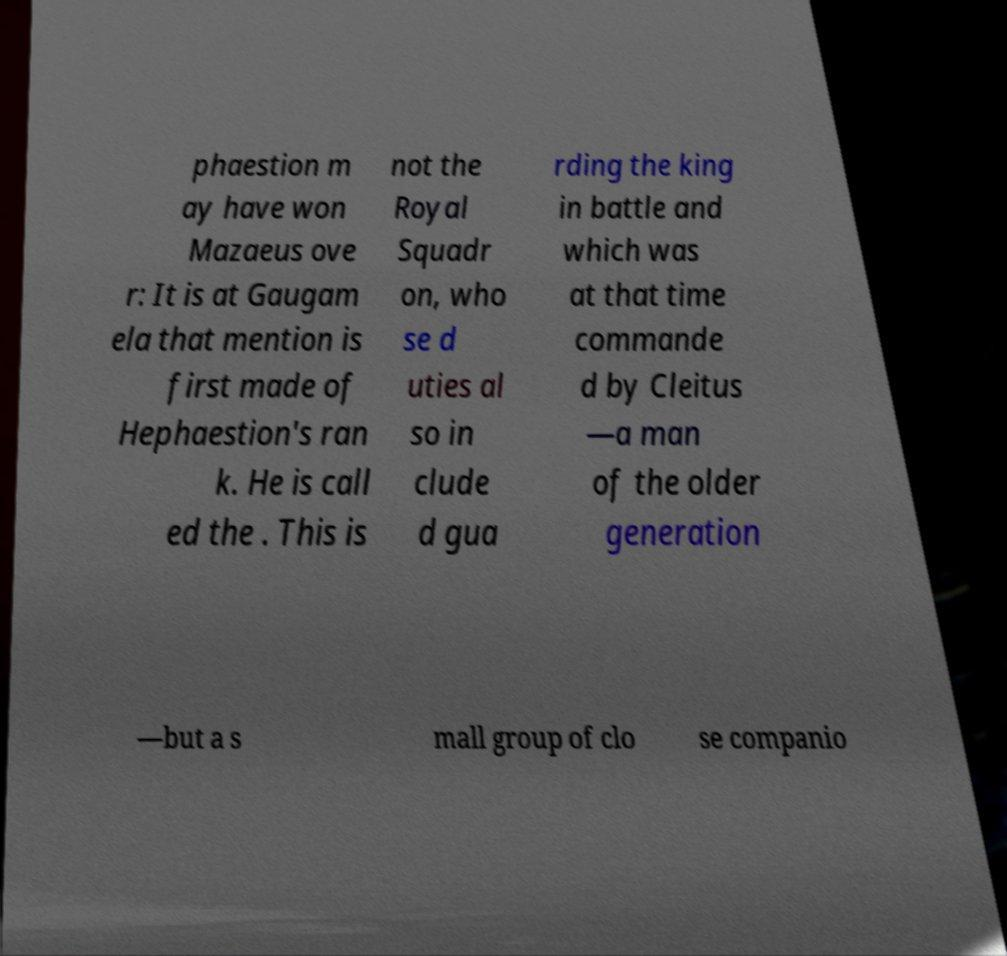Please read and relay the text visible in this image. What does it say? phaestion m ay have won Mazaeus ove r: It is at Gaugam ela that mention is first made of Hephaestion's ran k. He is call ed the . This is not the Royal Squadr on, who se d uties al so in clude d gua rding the king in battle and which was at that time commande d by Cleitus —a man of the older generation —but a s mall group of clo se companio 